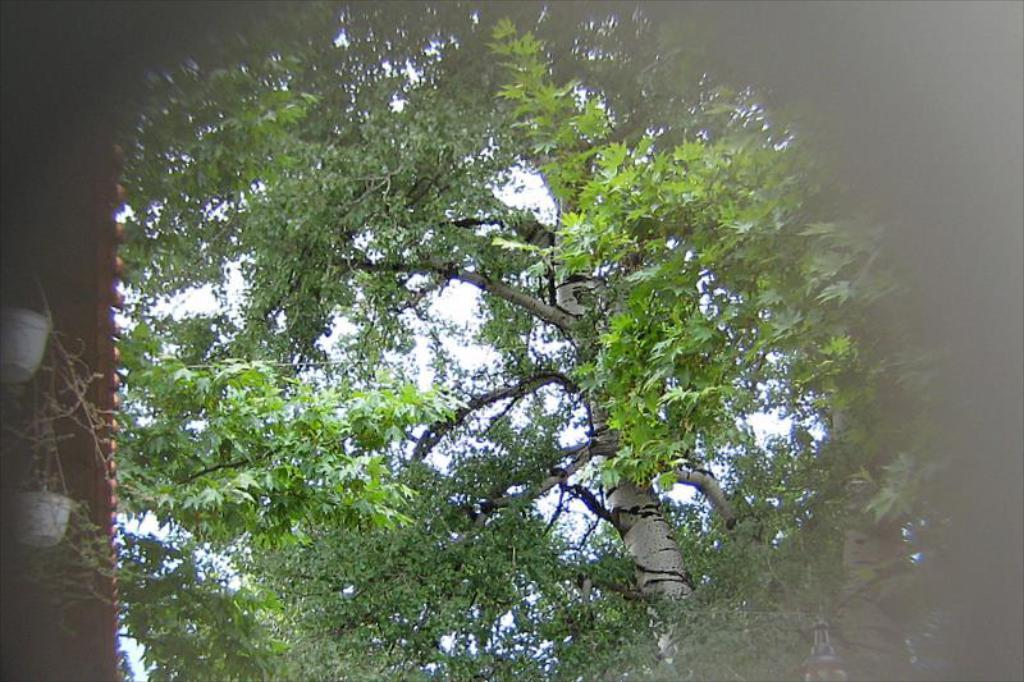What type of vegetation can be seen in the image? There are trees in the image. What object is located on the left side of the image? There is an object on the left side of the image that looks like a board. How many flower pots are present in the image? There are two flower pots in the image. What can be seen in the background of the image? The sky is visible in the background of the image. What type of pan is being used by the committee in the image? There is no committee or pan present in the image. Is the beggar holding a flower pot in the image? There is no beggar present in the image; it only features trees, a board-like object, and two flower pots. 